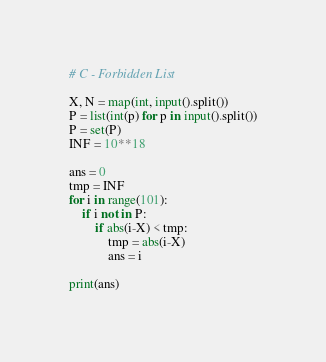Convert code to text. <code><loc_0><loc_0><loc_500><loc_500><_Python_># C - Forbidden List

X, N = map(int, input().split())
P = list(int(p) for p in input().split())
P = set(P)
INF = 10**18

ans = 0
tmp = INF
for i in range(101):
    if i not in P:
        if abs(i-X) < tmp:
            tmp = abs(i-X)
            ans = i

print(ans)


</code> 